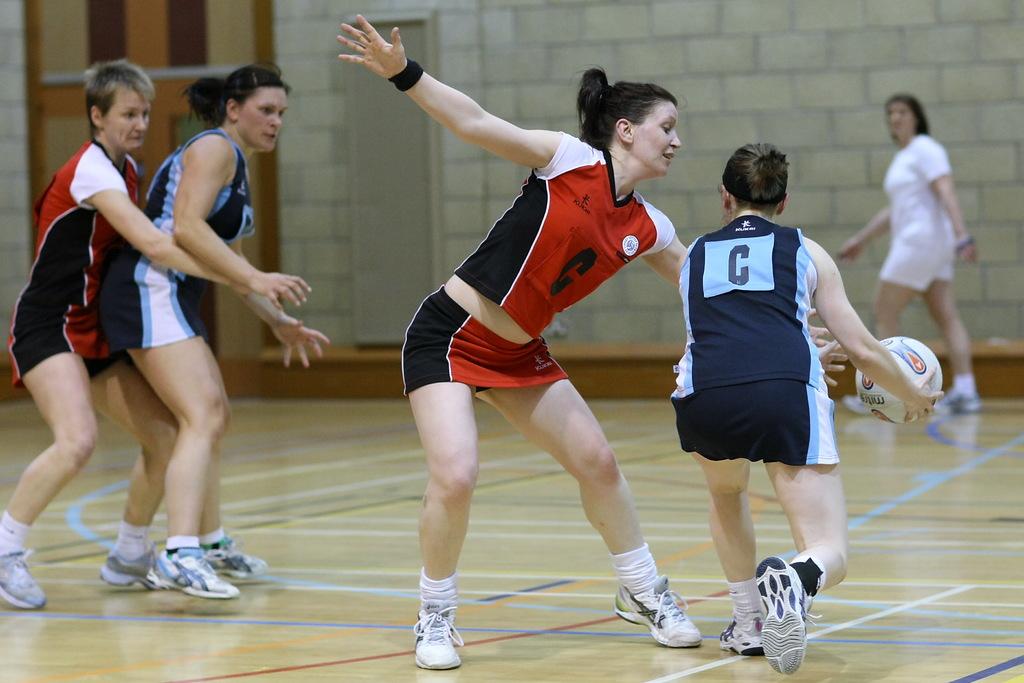What letter is on the front of the girl's shirt?
Give a very brief answer. C. 